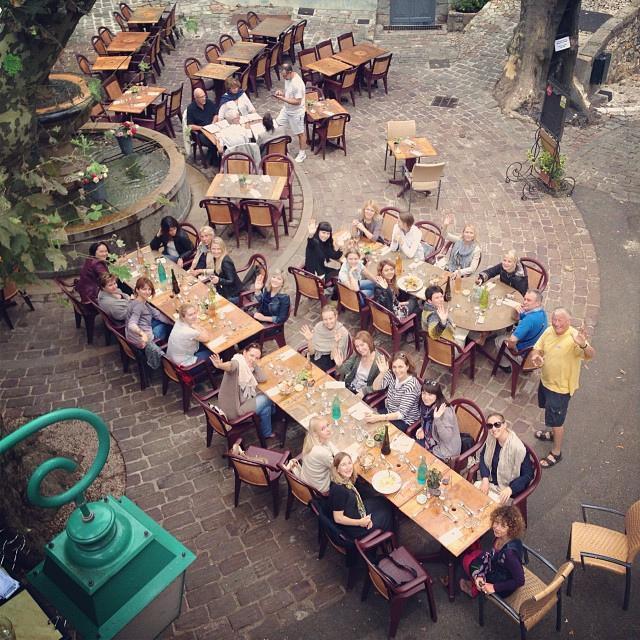How many chairs are there?
Give a very brief answer. 4. How many people are there?
Give a very brief answer. 9. How many dining tables can be seen?
Give a very brief answer. 5. 